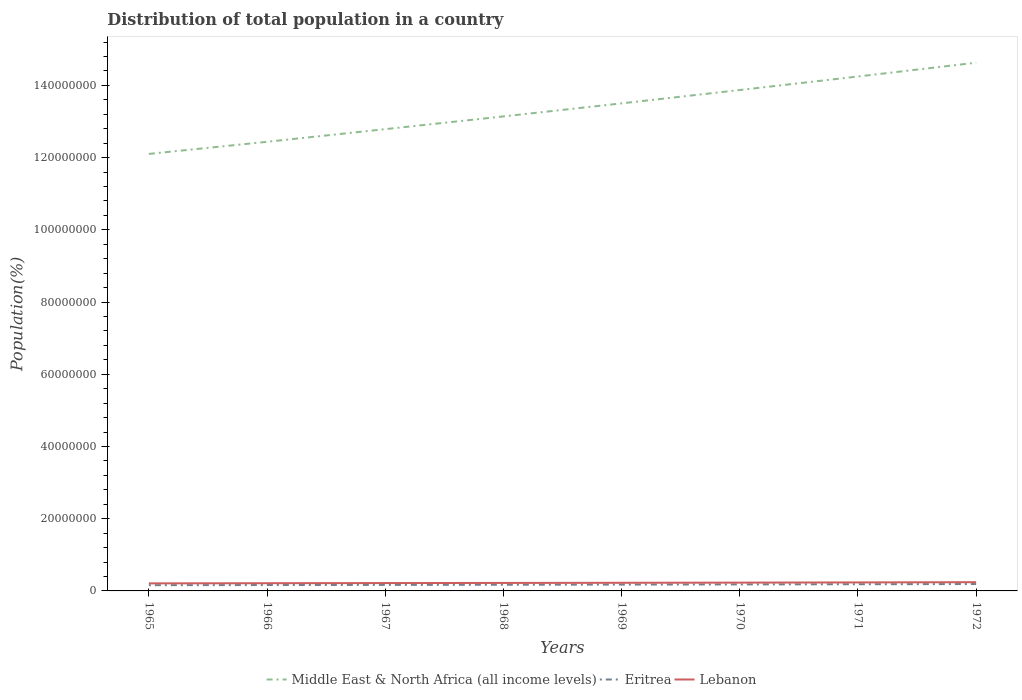How many different coloured lines are there?
Ensure brevity in your answer.  3. Is the number of lines equal to the number of legend labels?
Provide a short and direct response. Yes. Across all years, what is the maximum population of in Middle East & North Africa (all income levels)?
Your answer should be compact. 1.21e+08. In which year was the population of in Middle East & North Africa (all income levels) maximum?
Offer a terse response. 1965. What is the total population of in Eritrea in the graph?
Give a very brief answer. -8.16e+04. What is the difference between the highest and the second highest population of in Eritrea?
Your answer should be compact. 3.16e+05. What is the difference between the highest and the lowest population of in Eritrea?
Give a very brief answer. 4. Is the population of in Middle East & North Africa (all income levels) strictly greater than the population of in Lebanon over the years?
Make the answer very short. No. What is the difference between two consecutive major ticks on the Y-axis?
Provide a succinct answer. 2.00e+07. Are the values on the major ticks of Y-axis written in scientific E-notation?
Keep it short and to the point. No. Does the graph contain grids?
Your answer should be compact. No. Where does the legend appear in the graph?
Your answer should be compact. Bottom center. How many legend labels are there?
Offer a very short reply. 3. What is the title of the graph?
Provide a short and direct response. Distribution of total population in a country. What is the label or title of the X-axis?
Provide a short and direct response. Years. What is the label or title of the Y-axis?
Provide a short and direct response. Population(%). What is the Population(%) in Middle East & North Africa (all income levels) in 1965?
Offer a terse response. 1.21e+08. What is the Population(%) of Eritrea in 1965?
Your answer should be compact. 1.59e+06. What is the Population(%) of Lebanon in 1965?
Your answer should be very brief. 2.09e+06. What is the Population(%) in Middle East & North Africa (all income levels) in 1966?
Provide a succinct answer. 1.24e+08. What is the Population(%) in Eritrea in 1966?
Offer a very short reply. 1.63e+06. What is the Population(%) of Lebanon in 1966?
Your answer should be very brief. 2.14e+06. What is the Population(%) of Middle East & North Africa (all income levels) in 1967?
Your response must be concise. 1.28e+08. What is the Population(%) of Eritrea in 1967?
Your response must be concise. 1.67e+06. What is the Population(%) in Lebanon in 1967?
Your answer should be very brief. 2.17e+06. What is the Population(%) in Middle East & North Africa (all income levels) in 1968?
Your response must be concise. 1.31e+08. What is the Population(%) in Eritrea in 1968?
Ensure brevity in your answer.  1.71e+06. What is the Population(%) of Lebanon in 1968?
Offer a terse response. 2.21e+06. What is the Population(%) in Middle East & North Africa (all income levels) in 1969?
Keep it short and to the point. 1.35e+08. What is the Population(%) of Eritrea in 1969?
Offer a terse response. 1.76e+06. What is the Population(%) of Lebanon in 1969?
Give a very brief answer. 2.25e+06. What is the Population(%) in Middle East & North Africa (all income levels) in 1970?
Make the answer very short. 1.39e+08. What is the Population(%) in Eritrea in 1970?
Offer a very short reply. 1.81e+06. What is the Population(%) of Lebanon in 1970?
Give a very brief answer. 2.30e+06. What is the Population(%) in Middle East & North Africa (all income levels) in 1971?
Your response must be concise. 1.42e+08. What is the Population(%) in Eritrea in 1971?
Ensure brevity in your answer.  1.85e+06. What is the Population(%) of Lebanon in 1971?
Offer a terse response. 2.35e+06. What is the Population(%) in Middle East & North Africa (all income levels) in 1972?
Your answer should be compact. 1.46e+08. What is the Population(%) in Eritrea in 1972?
Provide a succinct answer. 1.91e+06. What is the Population(%) of Lebanon in 1972?
Provide a succinct answer. 2.42e+06. Across all years, what is the maximum Population(%) of Middle East & North Africa (all income levels)?
Your response must be concise. 1.46e+08. Across all years, what is the maximum Population(%) in Eritrea?
Provide a short and direct response. 1.91e+06. Across all years, what is the maximum Population(%) of Lebanon?
Make the answer very short. 2.42e+06. Across all years, what is the minimum Population(%) in Middle East & North Africa (all income levels)?
Provide a succinct answer. 1.21e+08. Across all years, what is the minimum Population(%) in Eritrea?
Provide a short and direct response. 1.59e+06. Across all years, what is the minimum Population(%) in Lebanon?
Provide a short and direct response. 2.09e+06. What is the total Population(%) in Middle East & North Africa (all income levels) in the graph?
Your answer should be compact. 1.07e+09. What is the total Population(%) of Eritrea in the graph?
Provide a short and direct response. 1.39e+07. What is the total Population(%) in Lebanon in the graph?
Provide a short and direct response. 1.79e+07. What is the difference between the Population(%) in Middle East & North Africa (all income levels) in 1965 and that in 1966?
Your answer should be compact. -3.36e+06. What is the difference between the Population(%) of Eritrea in 1965 and that in 1966?
Ensure brevity in your answer.  -4.01e+04. What is the difference between the Population(%) of Lebanon in 1965 and that in 1966?
Provide a short and direct response. -4.43e+04. What is the difference between the Population(%) in Middle East & North Africa (all income levels) in 1965 and that in 1967?
Offer a terse response. -6.86e+06. What is the difference between the Population(%) of Eritrea in 1965 and that in 1967?
Offer a terse response. -8.16e+04. What is the difference between the Population(%) of Lebanon in 1965 and that in 1967?
Offer a terse response. -8.25e+04. What is the difference between the Population(%) of Middle East & North Africa (all income levels) in 1965 and that in 1968?
Make the answer very short. -1.04e+07. What is the difference between the Population(%) of Eritrea in 1965 and that in 1968?
Your answer should be very brief. -1.25e+05. What is the difference between the Population(%) of Lebanon in 1965 and that in 1968?
Make the answer very short. -1.19e+05. What is the difference between the Population(%) in Middle East & North Africa (all income levels) in 1965 and that in 1969?
Give a very brief answer. -1.40e+07. What is the difference between the Population(%) of Eritrea in 1965 and that in 1969?
Give a very brief answer. -1.69e+05. What is the difference between the Population(%) in Lebanon in 1965 and that in 1969?
Ensure brevity in your answer.  -1.58e+05. What is the difference between the Population(%) in Middle East & North Africa (all income levels) in 1965 and that in 1970?
Provide a short and direct response. -1.77e+07. What is the difference between the Population(%) of Eritrea in 1965 and that in 1970?
Keep it short and to the point. -2.16e+05. What is the difference between the Population(%) of Lebanon in 1965 and that in 1970?
Keep it short and to the point. -2.05e+05. What is the difference between the Population(%) of Middle East & North Africa (all income levels) in 1965 and that in 1971?
Your answer should be very brief. -2.14e+07. What is the difference between the Population(%) of Eritrea in 1965 and that in 1971?
Your response must be concise. -2.65e+05. What is the difference between the Population(%) in Lebanon in 1965 and that in 1971?
Your answer should be very brief. -2.61e+05. What is the difference between the Population(%) in Middle East & North Africa (all income levels) in 1965 and that in 1972?
Your answer should be compact. -2.53e+07. What is the difference between the Population(%) of Eritrea in 1965 and that in 1972?
Provide a short and direct response. -3.16e+05. What is the difference between the Population(%) of Lebanon in 1965 and that in 1972?
Provide a succinct answer. -3.24e+05. What is the difference between the Population(%) of Middle East & North Africa (all income levels) in 1966 and that in 1967?
Provide a short and direct response. -3.50e+06. What is the difference between the Population(%) in Eritrea in 1966 and that in 1967?
Give a very brief answer. -4.15e+04. What is the difference between the Population(%) of Lebanon in 1966 and that in 1967?
Your answer should be very brief. -3.82e+04. What is the difference between the Population(%) of Middle East & North Africa (all income levels) in 1966 and that in 1968?
Ensure brevity in your answer.  -7.03e+06. What is the difference between the Population(%) in Eritrea in 1966 and that in 1968?
Your response must be concise. -8.45e+04. What is the difference between the Population(%) in Lebanon in 1966 and that in 1968?
Provide a short and direct response. -7.43e+04. What is the difference between the Population(%) in Middle East & North Africa (all income levels) in 1966 and that in 1969?
Offer a very short reply. -1.06e+07. What is the difference between the Population(%) of Eritrea in 1966 and that in 1969?
Offer a very short reply. -1.29e+05. What is the difference between the Population(%) of Lebanon in 1966 and that in 1969?
Provide a short and direct response. -1.14e+05. What is the difference between the Population(%) in Middle East & North Africa (all income levels) in 1966 and that in 1970?
Your response must be concise. -1.43e+07. What is the difference between the Population(%) of Eritrea in 1966 and that in 1970?
Ensure brevity in your answer.  -1.76e+05. What is the difference between the Population(%) of Lebanon in 1966 and that in 1970?
Keep it short and to the point. -1.61e+05. What is the difference between the Population(%) of Middle East & North Africa (all income levels) in 1966 and that in 1971?
Provide a short and direct response. -1.81e+07. What is the difference between the Population(%) in Eritrea in 1966 and that in 1971?
Your response must be concise. -2.25e+05. What is the difference between the Population(%) of Lebanon in 1966 and that in 1971?
Offer a terse response. -2.17e+05. What is the difference between the Population(%) of Middle East & North Africa (all income levels) in 1966 and that in 1972?
Your response must be concise. -2.19e+07. What is the difference between the Population(%) in Eritrea in 1966 and that in 1972?
Ensure brevity in your answer.  -2.76e+05. What is the difference between the Population(%) of Lebanon in 1966 and that in 1972?
Provide a short and direct response. -2.80e+05. What is the difference between the Population(%) in Middle East & North Africa (all income levels) in 1967 and that in 1968?
Keep it short and to the point. -3.53e+06. What is the difference between the Population(%) in Eritrea in 1967 and that in 1968?
Make the answer very short. -4.30e+04. What is the difference between the Population(%) in Lebanon in 1967 and that in 1968?
Your response must be concise. -3.61e+04. What is the difference between the Population(%) of Middle East & North Africa (all income levels) in 1967 and that in 1969?
Your response must be concise. -7.14e+06. What is the difference between the Population(%) of Eritrea in 1967 and that in 1969?
Give a very brief answer. -8.78e+04. What is the difference between the Population(%) of Lebanon in 1967 and that in 1969?
Provide a short and direct response. -7.58e+04. What is the difference between the Population(%) in Middle East & North Africa (all income levels) in 1967 and that in 1970?
Your answer should be compact. -1.08e+07. What is the difference between the Population(%) of Eritrea in 1967 and that in 1970?
Give a very brief answer. -1.35e+05. What is the difference between the Population(%) of Lebanon in 1967 and that in 1970?
Ensure brevity in your answer.  -1.23e+05. What is the difference between the Population(%) in Middle East & North Africa (all income levels) in 1967 and that in 1971?
Your answer should be very brief. -1.46e+07. What is the difference between the Population(%) in Eritrea in 1967 and that in 1971?
Provide a succinct answer. -1.84e+05. What is the difference between the Population(%) in Lebanon in 1967 and that in 1971?
Offer a very short reply. -1.79e+05. What is the difference between the Population(%) of Middle East & North Africa (all income levels) in 1967 and that in 1972?
Offer a terse response. -1.84e+07. What is the difference between the Population(%) in Eritrea in 1967 and that in 1972?
Your response must be concise. -2.35e+05. What is the difference between the Population(%) of Lebanon in 1967 and that in 1972?
Offer a very short reply. -2.42e+05. What is the difference between the Population(%) in Middle East & North Africa (all income levels) in 1968 and that in 1969?
Provide a short and direct response. -3.61e+06. What is the difference between the Population(%) of Eritrea in 1968 and that in 1969?
Offer a terse response. -4.48e+04. What is the difference between the Population(%) of Lebanon in 1968 and that in 1969?
Offer a terse response. -3.96e+04. What is the difference between the Population(%) of Middle East & North Africa (all income levels) in 1968 and that in 1970?
Provide a succinct answer. -7.31e+06. What is the difference between the Population(%) in Eritrea in 1968 and that in 1970?
Your response must be concise. -9.16e+04. What is the difference between the Population(%) in Lebanon in 1968 and that in 1970?
Keep it short and to the point. -8.64e+04. What is the difference between the Population(%) of Middle East & North Africa (all income levels) in 1968 and that in 1971?
Provide a succinct answer. -1.11e+07. What is the difference between the Population(%) of Eritrea in 1968 and that in 1971?
Ensure brevity in your answer.  -1.41e+05. What is the difference between the Population(%) of Lebanon in 1968 and that in 1971?
Offer a terse response. -1.43e+05. What is the difference between the Population(%) of Middle East & North Africa (all income levels) in 1968 and that in 1972?
Your response must be concise. -1.49e+07. What is the difference between the Population(%) in Eritrea in 1968 and that in 1972?
Keep it short and to the point. -1.92e+05. What is the difference between the Population(%) of Lebanon in 1968 and that in 1972?
Make the answer very short. -2.06e+05. What is the difference between the Population(%) of Middle East & North Africa (all income levels) in 1969 and that in 1970?
Give a very brief answer. -3.70e+06. What is the difference between the Population(%) in Eritrea in 1969 and that in 1970?
Give a very brief answer. -4.68e+04. What is the difference between the Population(%) in Lebanon in 1969 and that in 1970?
Provide a short and direct response. -4.68e+04. What is the difference between the Population(%) in Middle East & North Africa (all income levels) in 1969 and that in 1971?
Offer a terse response. -7.44e+06. What is the difference between the Population(%) in Eritrea in 1969 and that in 1971?
Provide a short and direct response. -9.57e+04. What is the difference between the Population(%) of Lebanon in 1969 and that in 1971?
Provide a succinct answer. -1.03e+05. What is the difference between the Population(%) of Middle East & North Africa (all income levels) in 1969 and that in 1972?
Offer a very short reply. -1.13e+07. What is the difference between the Population(%) in Eritrea in 1969 and that in 1972?
Give a very brief answer. -1.47e+05. What is the difference between the Population(%) in Lebanon in 1969 and that in 1972?
Your answer should be compact. -1.66e+05. What is the difference between the Population(%) in Middle East & North Africa (all income levels) in 1970 and that in 1971?
Offer a terse response. -3.75e+06. What is the difference between the Population(%) of Eritrea in 1970 and that in 1971?
Provide a succinct answer. -4.89e+04. What is the difference between the Population(%) of Lebanon in 1970 and that in 1971?
Your answer should be very brief. -5.62e+04. What is the difference between the Population(%) in Middle East & North Africa (all income levels) in 1970 and that in 1972?
Your response must be concise. -7.57e+06. What is the difference between the Population(%) of Eritrea in 1970 and that in 1972?
Make the answer very short. -9.99e+04. What is the difference between the Population(%) in Lebanon in 1970 and that in 1972?
Keep it short and to the point. -1.19e+05. What is the difference between the Population(%) of Middle East & North Africa (all income levels) in 1971 and that in 1972?
Give a very brief answer. -3.82e+06. What is the difference between the Population(%) of Eritrea in 1971 and that in 1972?
Offer a very short reply. -5.10e+04. What is the difference between the Population(%) of Lebanon in 1971 and that in 1972?
Provide a succinct answer. -6.32e+04. What is the difference between the Population(%) in Middle East & North Africa (all income levels) in 1965 and the Population(%) in Eritrea in 1966?
Your response must be concise. 1.19e+08. What is the difference between the Population(%) of Middle East & North Africa (all income levels) in 1965 and the Population(%) of Lebanon in 1966?
Give a very brief answer. 1.19e+08. What is the difference between the Population(%) of Eritrea in 1965 and the Population(%) of Lebanon in 1966?
Your answer should be very brief. -5.47e+05. What is the difference between the Population(%) in Middle East & North Africa (all income levels) in 1965 and the Population(%) in Eritrea in 1967?
Give a very brief answer. 1.19e+08. What is the difference between the Population(%) of Middle East & North Africa (all income levels) in 1965 and the Population(%) of Lebanon in 1967?
Ensure brevity in your answer.  1.19e+08. What is the difference between the Population(%) of Eritrea in 1965 and the Population(%) of Lebanon in 1967?
Make the answer very short. -5.86e+05. What is the difference between the Population(%) of Middle East & North Africa (all income levels) in 1965 and the Population(%) of Eritrea in 1968?
Ensure brevity in your answer.  1.19e+08. What is the difference between the Population(%) of Middle East & North Africa (all income levels) in 1965 and the Population(%) of Lebanon in 1968?
Your answer should be very brief. 1.19e+08. What is the difference between the Population(%) of Eritrea in 1965 and the Population(%) of Lebanon in 1968?
Give a very brief answer. -6.22e+05. What is the difference between the Population(%) in Middle East & North Africa (all income levels) in 1965 and the Population(%) in Eritrea in 1969?
Give a very brief answer. 1.19e+08. What is the difference between the Population(%) in Middle East & North Africa (all income levels) in 1965 and the Population(%) in Lebanon in 1969?
Your answer should be compact. 1.19e+08. What is the difference between the Population(%) in Eritrea in 1965 and the Population(%) in Lebanon in 1969?
Give a very brief answer. -6.61e+05. What is the difference between the Population(%) in Middle East & North Africa (all income levels) in 1965 and the Population(%) in Eritrea in 1970?
Your answer should be very brief. 1.19e+08. What is the difference between the Population(%) in Middle East & North Africa (all income levels) in 1965 and the Population(%) in Lebanon in 1970?
Provide a short and direct response. 1.19e+08. What is the difference between the Population(%) of Eritrea in 1965 and the Population(%) of Lebanon in 1970?
Provide a short and direct response. -7.08e+05. What is the difference between the Population(%) in Middle East & North Africa (all income levels) in 1965 and the Population(%) in Eritrea in 1971?
Your response must be concise. 1.19e+08. What is the difference between the Population(%) in Middle East & North Africa (all income levels) in 1965 and the Population(%) in Lebanon in 1971?
Give a very brief answer. 1.19e+08. What is the difference between the Population(%) of Eritrea in 1965 and the Population(%) of Lebanon in 1971?
Your response must be concise. -7.64e+05. What is the difference between the Population(%) in Middle East & North Africa (all income levels) in 1965 and the Population(%) in Eritrea in 1972?
Ensure brevity in your answer.  1.19e+08. What is the difference between the Population(%) of Middle East & North Africa (all income levels) in 1965 and the Population(%) of Lebanon in 1972?
Give a very brief answer. 1.19e+08. What is the difference between the Population(%) of Eritrea in 1965 and the Population(%) of Lebanon in 1972?
Give a very brief answer. -8.28e+05. What is the difference between the Population(%) in Middle East & North Africa (all income levels) in 1966 and the Population(%) in Eritrea in 1967?
Make the answer very short. 1.23e+08. What is the difference between the Population(%) in Middle East & North Africa (all income levels) in 1966 and the Population(%) in Lebanon in 1967?
Make the answer very short. 1.22e+08. What is the difference between the Population(%) of Eritrea in 1966 and the Population(%) of Lebanon in 1967?
Provide a short and direct response. -5.46e+05. What is the difference between the Population(%) in Middle East & North Africa (all income levels) in 1966 and the Population(%) in Eritrea in 1968?
Offer a terse response. 1.23e+08. What is the difference between the Population(%) in Middle East & North Africa (all income levels) in 1966 and the Population(%) in Lebanon in 1968?
Ensure brevity in your answer.  1.22e+08. What is the difference between the Population(%) of Eritrea in 1966 and the Population(%) of Lebanon in 1968?
Make the answer very short. -5.82e+05. What is the difference between the Population(%) in Middle East & North Africa (all income levels) in 1966 and the Population(%) in Eritrea in 1969?
Make the answer very short. 1.23e+08. What is the difference between the Population(%) in Middle East & North Africa (all income levels) in 1966 and the Population(%) in Lebanon in 1969?
Your answer should be compact. 1.22e+08. What is the difference between the Population(%) in Eritrea in 1966 and the Population(%) in Lebanon in 1969?
Ensure brevity in your answer.  -6.21e+05. What is the difference between the Population(%) of Middle East & North Africa (all income levels) in 1966 and the Population(%) of Eritrea in 1970?
Provide a short and direct response. 1.23e+08. What is the difference between the Population(%) in Middle East & North Africa (all income levels) in 1966 and the Population(%) in Lebanon in 1970?
Your answer should be very brief. 1.22e+08. What is the difference between the Population(%) of Eritrea in 1966 and the Population(%) of Lebanon in 1970?
Give a very brief answer. -6.68e+05. What is the difference between the Population(%) of Middle East & North Africa (all income levels) in 1966 and the Population(%) of Eritrea in 1971?
Offer a very short reply. 1.23e+08. What is the difference between the Population(%) in Middle East & North Africa (all income levels) in 1966 and the Population(%) in Lebanon in 1971?
Keep it short and to the point. 1.22e+08. What is the difference between the Population(%) in Eritrea in 1966 and the Population(%) in Lebanon in 1971?
Keep it short and to the point. -7.24e+05. What is the difference between the Population(%) in Middle East & North Africa (all income levels) in 1966 and the Population(%) in Eritrea in 1972?
Ensure brevity in your answer.  1.22e+08. What is the difference between the Population(%) in Middle East & North Africa (all income levels) in 1966 and the Population(%) in Lebanon in 1972?
Offer a very short reply. 1.22e+08. What is the difference between the Population(%) in Eritrea in 1966 and the Population(%) in Lebanon in 1972?
Ensure brevity in your answer.  -7.87e+05. What is the difference between the Population(%) in Middle East & North Africa (all income levels) in 1967 and the Population(%) in Eritrea in 1968?
Offer a terse response. 1.26e+08. What is the difference between the Population(%) of Middle East & North Africa (all income levels) in 1967 and the Population(%) of Lebanon in 1968?
Your answer should be compact. 1.26e+08. What is the difference between the Population(%) in Eritrea in 1967 and the Population(%) in Lebanon in 1968?
Offer a terse response. -5.40e+05. What is the difference between the Population(%) of Middle East & North Africa (all income levels) in 1967 and the Population(%) of Eritrea in 1969?
Your response must be concise. 1.26e+08. What is the difference between the Population(%) in Middle East & North Africa (all income levels) in 1967 and the Population(%) in Lebanon in 1969?
Ensure brevity in your answer.  1.26e+08. What is the difference between the Population(%) of Eritrea in 1967 and the Population(%) of Lebanon in 1969?
Provide a succinct answer. -5.80e+05. What is the difference between the Population(%) of Middle East & North Africa (all income levels) in 1967 and the Population(%) of Eritrea in 1970?
Provide a succinct answer. 1.26e+08. What is the difference between the Population(%) in Middle East & North Africa (all income levels) in 1967 and the Population(%) in Lebanon in 1970?
Your response must be concise. 1.26e+08. What is the difference between the Population(%) in Eritrea in 1967 and the Population(%) in Lebanon in 1970?
Provide a short and direct response. -6.27e+05. What is the difference between the Population(%) of Middle East & North Africa (all income levels) in 1967 and the Population(%) of Eritrea in 1971?
Ensure brevity in your answer.  1.26e+08. What is the difference between the Population(%) in Middle East & North Africa (all income levels) in 1967 and the Population(%) in Lebanon in 1971?
Make the answer very short. 1.26e+08. What is the difference between the Population(%) of Eritrea in 1967 and the Population(%) of Lebanon in 1971?
Provide a succinct answer. -6.83e+05. What is the difference between the Population(%) of Middle East & North Africa (all income levels) in 1967 and the Population(%) of Eritrea in 1972?
Ensure brevity in your answer.  1.26e+08. What is the difference between the Population(%) in Middle East & North Africa (all income levels) in 1967 and the Population(%) in Lebanon in 1972?
Make the answer very short. 1.25e+08. What is the difference between the Population(%) of Eritrea in 1967 and the Population(%) of Lebanon in 1972?
Your answer should be very brief. -7.46e+05. What is the difference between the Population(%) of Middle East & North Africa (all income levels) in 1968 and the Population(%) of Eritrea in 1969?
Your answer should be compact. 1.30e+08. What is the difference between the Population(%) of Middle East & North Africa (all income levels) in 1968 and the Population(%) of Lebanon in 1969?
Your response must be concise. 1.29e+08. What is the difference between the Population(%) of Eritrea in 1968 and the Population(%) of Lebanon in 1969?
Your answer should be very brief. -5.37e+05. What is the difference between the Population(%) in Middle East & North Africa (all income levels) in 1968 and the Population(%) in Eritrea in 1970?
Offer a very short reply. 1.30e+08. What is the difference between the Population(%) in Middle East & North Africa (all income levels) in 1968 and the Population(%) in Lebanon in 1970?
Offer a very short reply. 1.29e+08. What is the difference between the Population(%) in Eritrea in 1968 and the Population(%) in Lebanon in 1970?
Make the answer very short. -5.84e+05. What is the difference between the Population(%) of Middle East & North Africa (all income levels) in 1968 and the Population(%) of Eritrea in 1971?
Your answer should be very brief. 1.30e+08. What is the difference between the Population(%) in Middle East & North Africa (all income levels) in 1968 and the Population(%) in Lebanon in 1971?
Provide a short and direct response. 1.29e+08. What is the difference between the Population(%) in Eritrea in 1968 and the Population(%) in Lebanon in 1971?
Offer a very short reply. -6.40e+05. What is the difference between the Population(%) of Middle East & North Africa (all income levels) in 1968 and the Population(%) of Eritrea in 1972?
Provide a succinct answer. 1.30e+08. What is the difference between the Population(%) in Middle East & North Africa (all income levels) in 1968 and the Population(%) in Lebanon in 1972?
Make the answer very short. 1.29e+08. What is the difference between the Population(%) of Eritrea in 1968 and the Population(%) of Lebanon in 1972?
Offer a terse response. -7.03e+05. What is the difference between the Population(%) of Middle East & North Africa (all income levels) in 1969 and the Population(%) of Eritrea in 1970?
Your response must be concise. 1.33e+08. What is the difference between the Population(%) of Middle East & North Africa (all income levels) in 1969 and the Population(%) of Lebanon in 1970?
Keep it short and to the point. 1.33e+08. What is the difference between the Population(%) of Eritrea in 1969 and the Population(%) of Lebanon in 1970?
Your response must be concise. -5.39e+05. What is the difference between the Population(%) of Middle East & North Africa (all income levels) in 1969 and the Population(%) of Eritrea in 1971?
Your answer should be compact. 1.33e+08. What is the difference between the Population(%) of Middle East & North Africa (all income levels) in 1969 and the Population(%) of Lebanon in 1971?
Offer a terse response. 1.33e+08. What is the difference between the Population(%) in Eritrea in 1969 and the Population(%) in Lebanon in 1971?
Provide a succinct answer. -5.95e+05. What is the difference between the Population(%) in Middle East & North Africa (all income levels) in 1969 and the Population(%) in Eritrea in 1972?
Provide a succinct answer. 1.33e+08. What is the difference between the Population(%) of Middle East & North Africa (all income levels) in 1969 and the Population(%) of Lebanon in 1972?
Your answer should be compact. 1.33e+08. What is the difference between the Population(%) in Eritrea in 1969 and the Population(%) in Lebanon in 1972?
Your answer should be compact. -6.58e+05. What is the difference between the Population(%) in Middle East & North Africa (all income levels) in 1970 and the Population(%) in Eritrea in 1971?
Your answer should be very brief. 1.37e+08. What is the difference between the Population(%) in Middle East & North Africa (all income levels) in 1970 and the Population(%) in Lebanon in 1971?
Your answer should be very brief. 1.36e+08. What is the difference between the Population(%) of Eritrea in 1970 and the Population(%) of Lebanon in 1971?
Your answer should be very brief. -5.48e+05. What is the difference between the Population(%) in Middle East & North Africa (all income levels) in 1970 and the Population(%) in Eritrea in 1972?
Give a very brief answer. 1.37e+08. What is the difference between the Population(%) in Middle East & North Africa (all income levels) in 1970 and the Population(%) in Lebanon in 1972?
Your answer should be very brief. 1.36e+08. What is the difference between the Population(%) of Eritrea in 1970 and the Population(%) of Lebanon in 1972?
Your response must be concise. -6.11e+05. What is the difference between the Population(%) of Middle East & North Africa (all income levels) in 1971 and the Population(%) of Eritrea in 1972?
Provide a short and direct response. 1.41e+08. What is the difference between the Population(%) in Middle East & North Africa (all income levels) in 1971 and the Population(%) in Lebanon in 1972?
Provide a short and direct response. 1.40e+08. What is the difference between the Population(%) in Eritrea in 1971 and the Population(%) in Lebanon in 1972?
Make the answer very short. -5.62e+05. What is the average Population(%) in Middle East & North Africa (all income levels) per year?
Your answer should be compact. 1.33e+08. What is the average Population(%) of Eritrea per year?
Offer a terse response. 1.74e+06. What is the average Population(%) in Lebanon per year?
Your answer should be very brief. 2.24e+06. In the year 1965, what is the difference between the Population(%) in Middle East & North Africa (all income levels) and Population(%) in Eritrea?
Offer a very short reply. 1.19e+08. In the year 1965, what is the difference between the Population(%) of Middle East & North Africa (all income levels) and Population(%) of Lebanon?
Offer a very short reply. 1.19e+08. In the year 1965, what is the difference between the Population(%) of Eritrea and Population(%) of Lebanon?
Keep it short and to the point. -5.03e+05. In the year 1966, what is the difference between the Population(%) of Middle East & North Africa (all income levels) and Population(%) of Eritrea?
Make the answer very short. 1.23e+08. In the year 1966, what is the difference between the Population(%) of Middle East & North Africa (all income levels) and Population(%) of Lebanon?
Keep it short and to the point. 1.22e+08. In the year 1966, what is the difference between the Population(%) of Eritrea and Population(%) of Lebanon?
Keep it short and to the point. -5.07e+05. In the year 1967, what is the difference between the Population(%) of Middle East & North Africa (all income levels) and Population(%) of Eritrea?
Give a very brief answer. 1.26e+08. In the year 1967, what is the difference between the Population(%) of Middle East & North Africa (all income levels) and Population(%) of Lebanon?
Ensure brevity in your answer.  1.26e+08. In the year 1967, what is the difference between the Population(%) of Eritrea and Population(%) of Lebanon?
Offer a terse response. -5.04e+05. In the year 1968, what is the difference between the Population(%) in Middle East & North Africa (all income levels) and Population(%) in Eritrea?
Offer a very short reply. 1.30e+08. In the year 1968, what is the difference between the Population(%) of Middle East & North Africa (all income levels) and Population(%) of Lebanon?
Your answer should be very brief. 1.29e+08. In the year 1968, what is the difference between the Population(%) in Eritrea and Population(%) in Lebanon?
Make the answer very short. -4.97e+05. In the year 1969, what is the difference between the Population(%) of Middle East & North Africa (all income levels) and Population(%) of Eritrea?
Make the answer very short. 1.33e+08. In the year 1969, what is the difference between the Population(%) in Middle East & North Africa (all income levels) and Population(%) in Lebanon?
Provide a short and direct response. 1.33e+08. In the year 1969, what is the difference between the Population(%) in Eritrea and Population(%) in Lebanon?
Your response must be concise. -4.92e+05. In the year 1970, what is the difference between the Population(%) in Middle East & North Africa (all income levels) and Population(%) in Eritrea?
Make the answer very short. 1.37e+08. In the year 1970, what is the difference between the Population(%) in Middle East & North Africa (all income levels) and Population(%) in Lebanon?
Your response must be concise. 1.36e+08. In the year 1970, what is the difference between the Population(%) in Eritrea and Population(%) in Lebanon?
Offer a terse response. -4.92e+05. In the year 1971, what is the difference between the Population(%) of Middle East & North Africa (all income levels) and Population(%) of Eritrea?
Your response must be concise. 1.41e+08. In the year 1971, what is the difference between the Population(%) in Middle East & North Africa (all income levels) and Population(%) in Lebanon?
Your answer should be very brief. 1.40e+08. In the year 1971, what is the difference between the Population(%) of Eritrea and Population(%) of Lebanon?
Ensure brevity in your answer.  -4.99e+05. In the year 1972, what is the difference between the Population(%) of Middle East & North Africa (all income levels) and Population(%) of Eritrea?
Offer a very short reply. 1.44e+08. In the year 1972, what is the difference between the Population(%) of Middle East & North Africa (all income levels) and Population(%) of Lebanon?
Make the answer very short. 1.44e+08. In the year 1972, what is the difference between the Population(%) in Eritrea and Population(%) in Lebanon?
Provide a short and direct response. -5.11e+05. What is the ratio of the Population(%) of Middle East & North Africa (all income levels) in 1965 to that in 1966?
Your answer should be compact. 0.97. What is the ratio of the Population(%) of Eritrea in 1965 to that in 1966?
Your answer should be very brief. 0.98. What is the ratio of the Population(%) of Lebanon in 1965 to that in 1966?
Make the answer very short. 0.98. What is the ratio of the Population(%) of Middle East & North Africa (all income levels) in 1965 to that in 1967?
Provide a succinct answer. 0.95. What is the ratio of the Population(%) of Eritrea in 1965 to that in 1967?
Offer a terse response. 0.95. What is the ratio of the Population(%) of Lebanon in 1965 to that in 1967?
Make the answer very short. 0.96. What is the ratio of the Population(%) in Middle East & North Africa (all income levels) in 1965 to that in 1968?
Offer a terse response. 0.92. What is the ratio of the Population(%) of Eritrea in 1965 to that in 1968?
Provide a short and direct response. 0.93. What is the ratio of the Population(%) in Lebanon in 1965 to that in 1968?
Offer a very short reply. 0.95. What is the ratio of the Population(%) in Middle East & North Africa (all income levels) in 1965 to that in 1969?
Give a very brief answer. 0.9. What is the ratio of the Population(%) of Eritrea in 1965 to that in 1969?
Your answer should be compact. 0.9. What is the ratio of the Population(%) of Lebanon in 1965 to that in 1969?
Your response must be concise. 0.93. What is the ratio of the Population(%) of Middle East & North Africa (all income levels) in 1965 to that in 1970?
Keep it short and to the point. 0.87. What is the ratio of the Population(%) of Eritrea in 1965 to that in 1970?
Provide a short and direct response. 0.88. What is the ratio of the Population(%) in Lebanon in 1965 to that in 1970?
Provide a short and direct response. 0.91. What is the ratio of the Population(%) in Middle East & North Africa (all income levels) in 1965 to that in 1971?
Keep it short and to the point. 0.85. What is the ratio of the Population(%) of Eritrea in 1965 to that in 1971?
Provide a short and direct response. 0.86. What is the ratio of the Population(%) in Lebanon in 1965 to that in 1971?
Your response must be concise. 0.89. What is the ratio of the Population(%) of Middle East & North Africa (all income levels) in 1965 to that in 1972?
Give a very brief answer. 0.83. What is the ratio of the Population(%) of Eritrea in 1965 to that in 1972?
Provide a short and direct response. 0.83. What is the ratio of the Population(%) in Lebanon in 1965 to that in 1972?
Your answer should be very brief. 0.87. What is the ratio of the Population(%) of Middle East & North Africa (all income levels) in 1966 to that in 1967?
Your answer should be compact. 0.97. What is the ratio of the Population(%) of Eritrea in 1966 to that in 1967?
Your answer should be very brief. 0.98. What is the ratio of the Population(%) of Lebanon in 1966 to that in 1967?
Provide a short and direct response. 0.98. What is the ratio of the Population(%) in Middle East & North Africa (all income levels) in 1966 to that in 1968?
Provide a short and direct response. 0.95. What is the ratio of the Population(%) of Eritrea in 1966 to that in 1968?
Make the answer very short. 0.95. What is the ratio of the Population(%) of Lebanon in 1966 to that in 1968?
Provide a short and direct response. 0.97. What is the ratio of the Population(%) in Middle East & North Africa (all income levels) in 1966 to that in 1969?
Ensure brevity in your answer.  0.92. What is the ratio of the Population(%) in Eritrea in 1966 to that in 1969?
Keep it short and to the point. 0.93. What is the ratio of the Population(%) in Lebanon in 1966 to that in 1969?
Offer a very short reply. 0.95. What is the ratio of the Population(%) of Middle East & North Africa (all income levels) in 1966 to that in 1970?
Your response must be concise. 0.9. What is the ratio of the Population(%) in Eritrea in 1966 to that in 1970?
Keep it short and to the point. 0.9. What is the ratio of the Population(%) in Middle East & North Africa (all income levels) in 1966 to that in 1971?
Offer a very short reply. 0.87. What is the ratio of the Population(%) of Eritrea in 1966 to that in 1971?
Your answer should be very brief. 0.88. What is the ratio of the Population(%) of Lebanon in 1966 to that in 1971?
Provide a succinct answer. 0.91. What is the ratio of the Population(%) in Middle East & North Africa (all income levels) in 1966 to that in 1972?
Provide a succinct answer. 0.85. What is the ratio of the Population(%) of Eritrea in 1966 to that in 1972?
Offer a very short reply. 0.86. What is the ratio of the Population(%) in Lebanon in 1966 to that in 1972?
Provide a short and direct response. 0.88. What is the ratio of the Population(%) in Middle East & North Africa (all income levels) in 1967 to that in 1968?
Provide a succinct answer. 0.97. What is the ratio of the Population(%) of Eritrea in 1967 to that in 1968?
Ensure brevity in your answer.  0.97. What is the ratio of the Population(%) in Lebanon in 1967 to that in 1968?
Your answer should be very brief. 0.98. What is the ratio of the Population(%) of Middle East & North Africa (all income levels) in 1967 to that in 1969?
Your answer should be very brief. 0.95. What is the ratio of the Population(%) in Lebanon in 1967 to that in 1969?
Your response must be concise. 0.97. What is the ratio of the Population(%) of Middle East & North Africa (all income levels) in 1967 to that in 1970?
Offer a very short reply. 0.92. What is the ratio of the Population(%) in Eritrea in 1967 to that in 1970?
Give a very brief answer. 0.93. What is the ratio of the Population(%) of Lebanon in 1967 to that in 1970?
Your answer should be very brief. 0.95. What is the ratio of the Population(%) in Middle East & North Africa (all income levels) in 1967 to that in 1971?
Your answer should be very brief. 0.9. What is the ratio of the Population(%) of Eritrea in 1967 to that in 1971?
Keep it short and to the point. 0.9. What is the ratio of the Population(%) in Lebanon in 1967 to that in 1971?
Keep it short and to the point. 0.92. What is the ratio of the Population(%) of Middle East & North Africa (all income levels) in 1967 to that in 1972?
Provide a succinct answer. 0.87. What is the ratio of the Population(%) in Eritrea in 1967 to that in 1972?
Offer a terse response. 0.88. What is the ratio of the Population(%) in Lebanon in 1967 to that in 1972?
Make the answer very short. 0.9. What is the ratio of the Population(%) of Middle East & North Africa (all income levels) in 1968 to that in 1969?
Offer a terse response. 0.97. What is the ratio of the Population(%) in Eritrea in 1968 to that in 1969?
Provide a short and direct response. 0.97. What is the ratio of the Population(%) of Lebanon in 1968 to that in 1969?
Your answer should be compact. 0.98. What is the ratio of the Population(%) in Middle East & North Africa (all income levels) in 1968 to that in 1970?
Provide a succinct answer. 0.95. What is the ratio of the Population(%) in Eritrea in 1968 to that in 1970?
Your response must be concise. 0.95. What is the ratio of the Population(%) of Lebanon in 1968 to that in 1970?
Your answer should be compact. 0.96. What is the ratio of the Population(%) in Middle East & North Africa (all income levels) in 1968 to that in 1971?
Offer a very short reply. 0.92. What is the ratio of the Population(%) of Eritrea in 1968 to that in 1971?
Offer a terse response. 0.92. What is the ratio of the Population(%) of Lebanon in 1968 to that in 1971?
Provide a short and direct response. 0.94. What is the ratio of the Population(%) in Middle East & North Africa (all income levels) in 1968 to that in 1972?
Make the answer very short. 0.9. What is the ratio of the Population(%) in Eritrea in 1968 to that in 1972?
Your answer should be compact. 0.9. What is the ratio of the Population(%) in Lebanon in 1968 to that in 1972?
Keep it short and to the point. 0.91. What is the ratio of the Population(%) in Middle East & North Africa (all income levels) in 1969 to that in 1970?
Offer a very short reply. 0.97. What is the ratio of the Population(%) in Eritrea in 1969 to that in 1970?
Your answer should be very brief. 0.97. What is the ratio of the Population(%) in Lebanon in 1969 to that in 1970?
Your answer should be very brief. 0.98. What is the ratio of the Population(%) of Middle East & North Africa (all income levels) in 1969 to that in 1971?
Your response must be concise. 0.95. What is the ratio of the Population(%) in Eritrea in 1969 to that in 1971?
Offer a very short reply. 0.95. What is the ratio of the Population(%) of Lebanon in 1969 to that in 1971?
Offer a terse response. 0.96. What is the ratio of the Population(%) of Middle East & North Africa (all income levels) in 1969 to that in 1972?
Provide a short and direct response. 0.92. What is the ratio of the Population(%) in Eritrea in 1969 to that in 1972?
Give a very brief answer. 0.92. What is the ratio of the Population(%) in Lebanon in 1969 to that in 1972?
Keep it short and to the point. 0.93. What is the ratio of the Population(%) of Middle East & North Africa (all income levels) in 1970 to that in 1971?
Give a very brief answer. 0.97. What is the ratio of the Population(%) of Eritrea in 1970 to that in 1971?
Your response must be concise. 0.97. What is the ratio of the Population(%) in Lebanon in 1970 to that in 1971?
Ensure brevity in your answer.  0.98. What is the ratio of the Population(%) in Middle East & North Africa (all income levels) in 1970 to that in 1972?
Provide a succinct answer. 0.95. What is the ratio of the Population(%) of Eritrea in 1970 to that in 1972?
Give a very brief answer. 0.95. What is the ratio of the Population(%) of Lebanon in 1970 to that in 1972?
Your answer should be compact. 0.95. What is the ratio of the Population(%) of Middle East & North Africa (all income levels) in 1971 to that in 1972?
Give a very brief answer. 0.97. What is the ratio of the Population(%) in Eritrea in 1971 to that in 1972?
Ensure brevity in your answer.  0.97. What is the ratio of the Population(%) of Lebanon in 1971 to that in 1972?
Your answer should be compact. 0.97. What is the difference between the highest and the second highest Population(%) in Middle East & North Africa (all income levels)?
Offer a terse response. 3.82e+06. What is the difference between the highest and the second highest Population(%) of Eritrea?
Provide a succinct answer. 5.10e+04. What is the difference between the highest and the second highest Population(%) in Lebanon?
Provide a succinct answer. 6.32e+04. What is the difference between the highest and the lowest Population(%) of Middle East & North Africa (all income levels)?
Give a very brief answer. 2.53e+07. What is the difference between the highest and the lowest Population(%) in Eritrea?
Offer a terse response. 3.16e+05. What is the difference between the highest and the lowest Population(%) in Lebanon?
Offer a very short reply. 3.24e+05. 